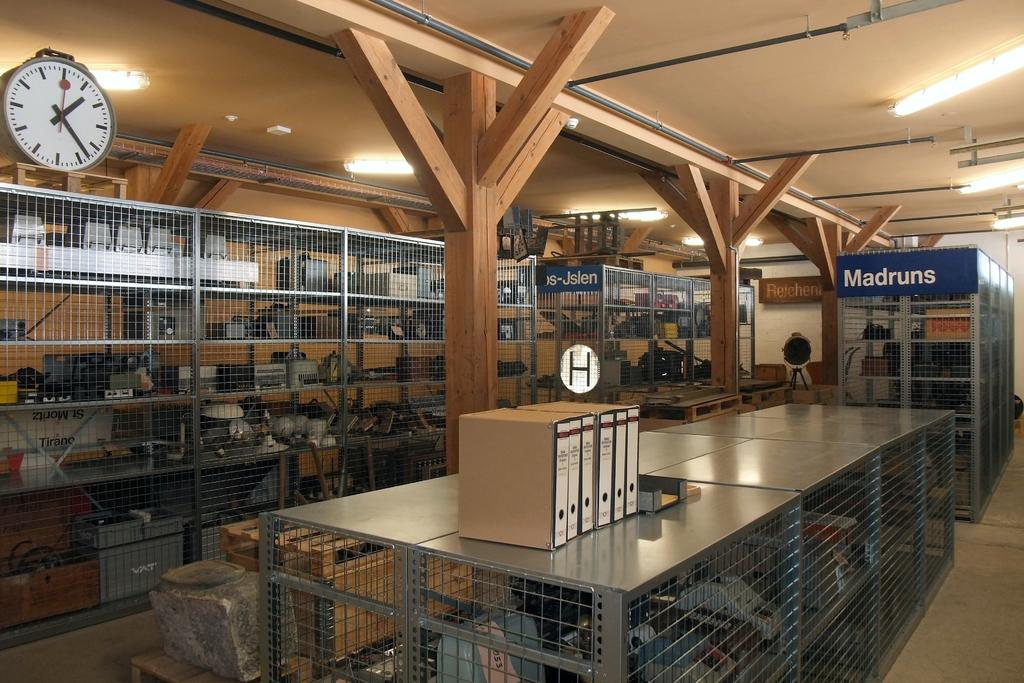<image>
Give a short and clear explanation of the subsequent image. A clock above a metal cage displays the time of one twenty three. 